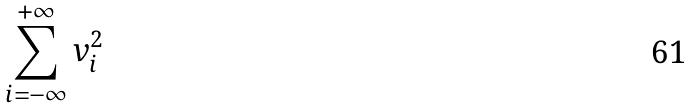<formula> <loc_0><loc_0><loc_500><loc_500>\sum _ { i = - \infty } ^ { + \infty } v _ { i } ^ { 2 }</formula> 